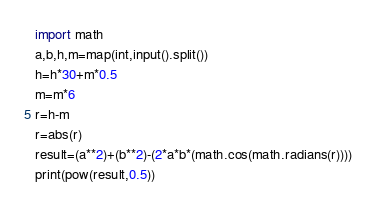Convert code to text. <code><loc_0><loc_0><loc_500><loc_500><_Python_>import math
a,b,h,m=map(int,input().split())
h=h*30+m*0.5
m=m*6
r=h-m
r=abs(r)
result=(a**2)+(b**2)-(2*a*b*(math.cos(math.radians(r))))
print(pow(result,0.5))</code> 